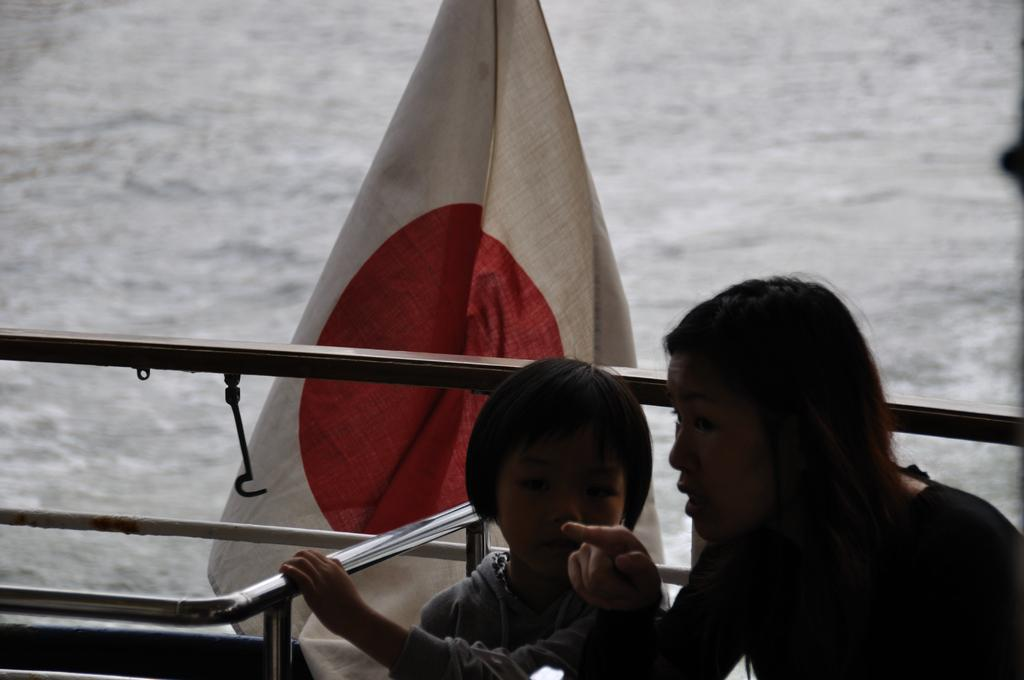What is the main object in the image? There is an object that looks like a boat in the image. How many people are in the boat? There are two persons in the boat. What is attached to the boat? There is a flag in the boat. What can be seen in the background of the image? There is water visible in the background of the image. What type of tub can be seen in the boat? There is no tub present in the boat or the image. 